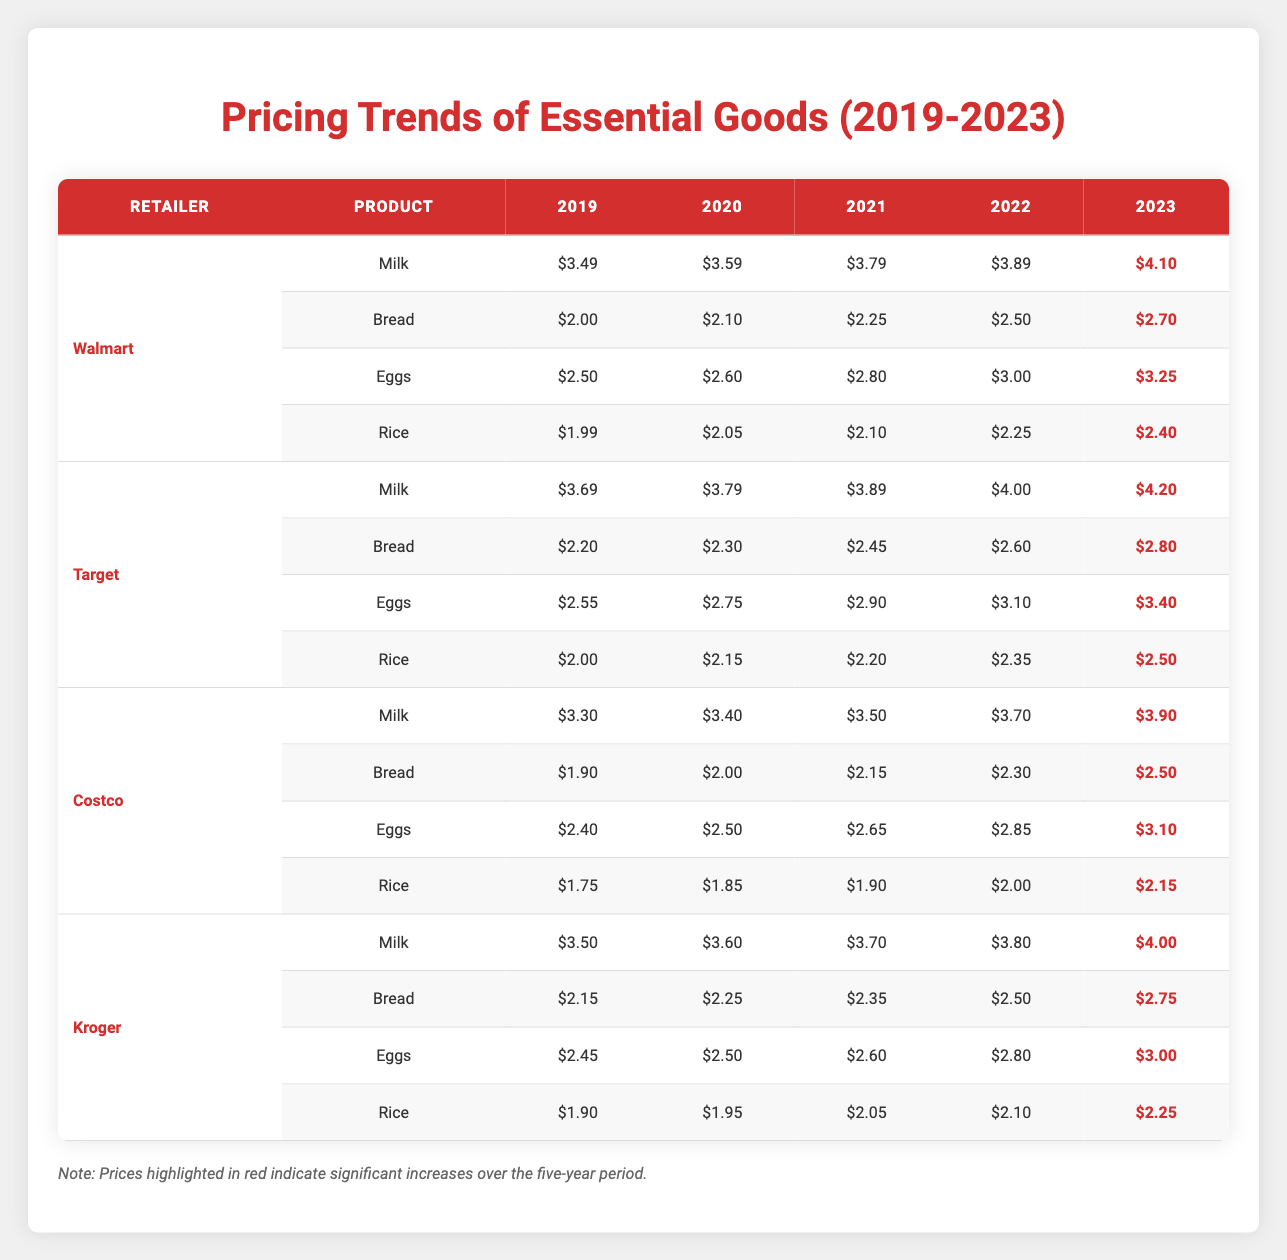What was the price of milk at Walmart in 2021? Refer to the "Walmart" row and find the "Milk" column under 2021, which shows the price as $3.79.
Answer: $3.79 Which retailer had the highest price for eggs in 2022? Check the prices for eggs for all retailers in 2022. Walmart: $3.00, Target: $3.10, Costco: $2.85, Kroger: $2.80. Target has the highest price at $3.10.
Answer: Target What is the price difference for rice between 2019 and 2023 at Costco? For Costco, rice prices are $1.75 in 2019 and $2.15 in 2023. The difference is $2.15 - $1.75 = $0.40.
Answer: $0.40 What was the average price of bread at all retailers in 2023? Add the prices of bread for all retailers in 2023: Walmart: $2.70, Target: $2.80, Costco: $2.50, Kroger: $2.75. Total is $2.70 + $2.80 + $2.50 + $2.75 = $10.75. Divide by 4 (the number of retailers) to get the average: $10.75 / 4 = $2.6875, which rounds to $2.69.
Answer: $2.69 Did the price of milk increase every year at Walmart? Check the yearly prices for milk at Walmart: 2019: $3.49, 2020: $3.59, 2021: $3.79, 2022: $3.89, 2023: $4.10. Since all prices increased year by year, the answer is yes.
Answer: Yes How much has the price of eggs increased at Kroger from 2019 to 2023? At Kroger, eggs were $2.45 in 2019 and $3.00 in 2023. The increase is $3.00 - $2.45 = $0.55.
Answer: $0.55 Which retailer consistently had the lowest price for rice over the five years? Compare rice prices for all retailers each year. Costco has the lowest prices throughout: $1.75 (2019), $1.85 (2020), $1.90 (2021), $2.00 (2022), and $2.15 (2023).
Answer: Costco What is the total price for milk across all retailers in 2020? Gather the 2020 milk prices: Walmart: $3.59, Target: $3.79, Costco: $3.40, Kroger: $3.60. Total is $3.59 + $3.79 + $3.40 + $3.60 = $14.38.
Answer: $14.38 Which retailer had the greatest price increase for bread from 2019 to 2023? Calculate the price increase for bread for each retailer: Walmart: $2.70 - $2.00 = $0.70, Target: $2.80 - $2.20 = $0.60, Costco: $2.50 - $1.90 = $0.60, Kroger: $2.75 - $2.15 = $0.60. The greatest increase is from Walmart with $0.70.
Answer: Walmart 